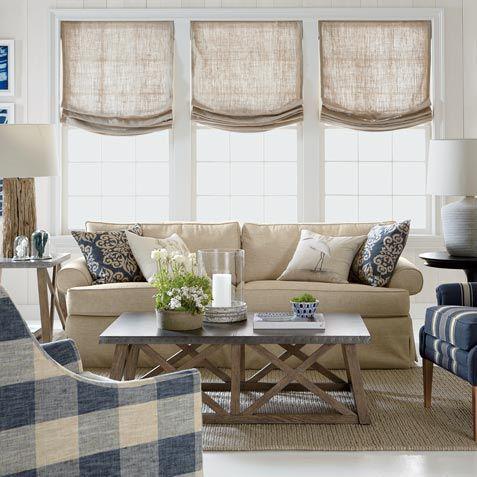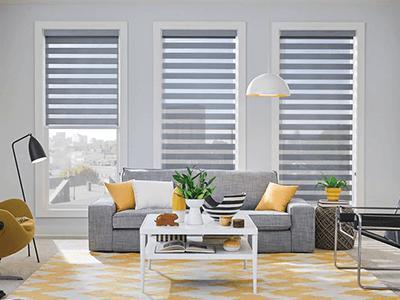The first image is the image on the left, the second image is the image on the right. For the images displayed, is the sentence "A room features a table on a rug in front of a couch, which is in front of windows with three colored shades." factually correct? Answer yes or no. Yes. The first image is the image on the left, the second image is the image on the right. Analyze the images presented: Is the assertion "Each image shows three blinds covering three windows side-by-side on the same wall." valid? Answer yes or no. Yes. 